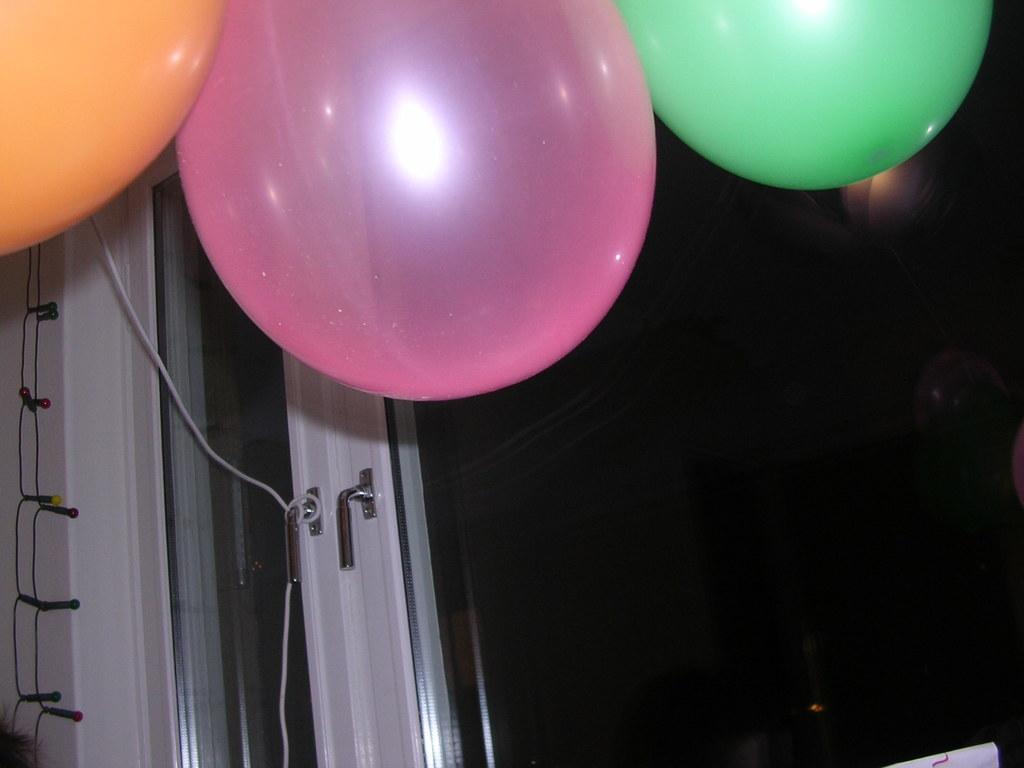Describe this image in one or two sentences. In this image there is a glass door, at the top of the image there are balloons and few colorful lights hanging. 